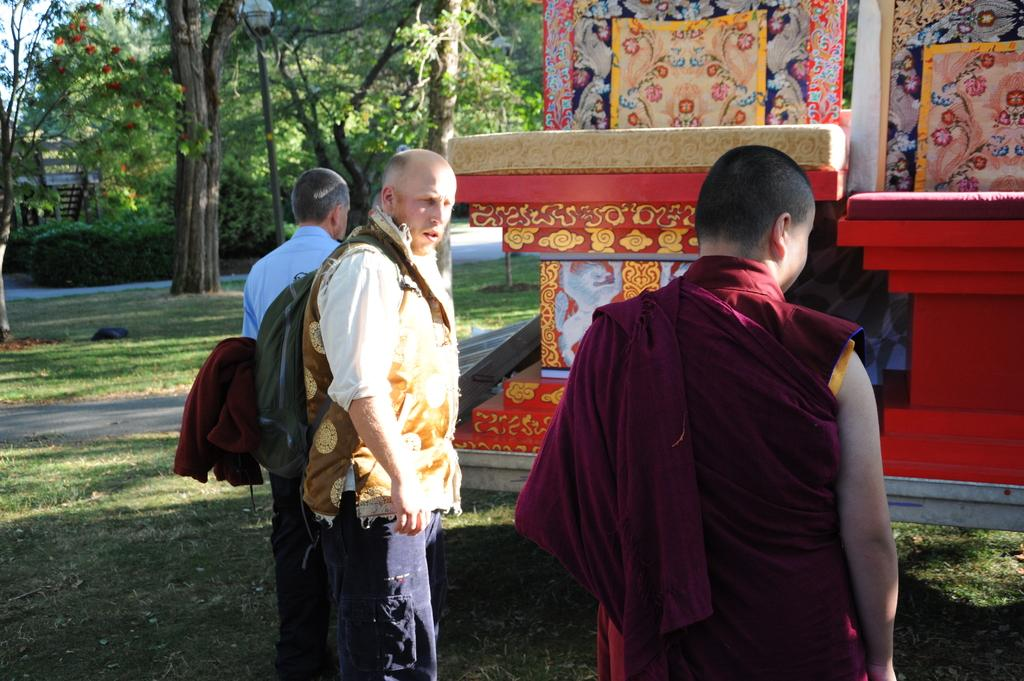How many people are standing on the grass in the image? There are three persons standing on the grass in the image. What can be seen in the background of the image? There are many trees in the background of the image. What is the color of the monument in the image? The monument in the image is red. What else can be seen in the image besides the people and trees? A road is visible in the image. What type of meat is hanging from the trees in the image? There is no meat hanging from the trees in the image; it only features trees and other elements mentioned in the facts. 